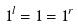<formula> <loc_0><loc_0><loc_500><loc_500>1 ^ { l } = 1 = 1 ^ { r }</formula> 